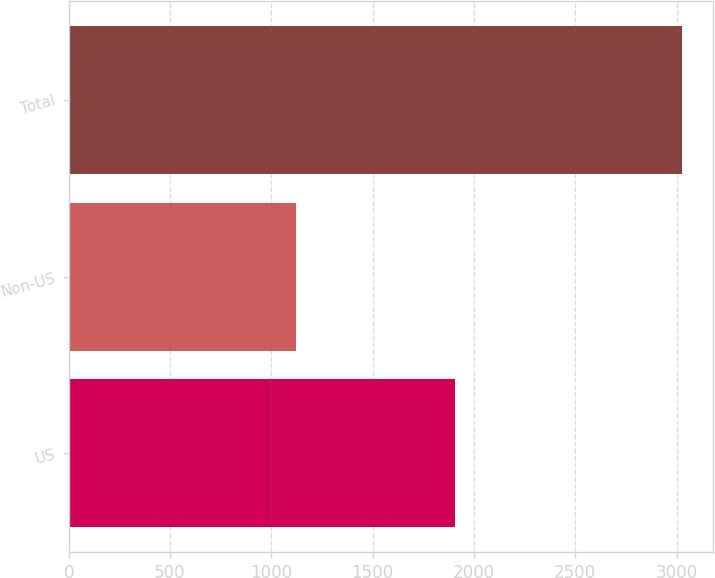Convert chart to OTSL. <chart><loc_0><loc_0><loc_500><loc_500><bar_chart><fcel>US<fcel>Non-US<fcel>Total<nl><fcel>1904.1<fcel>1122.5<fcel>3026.6<nl></chart> 